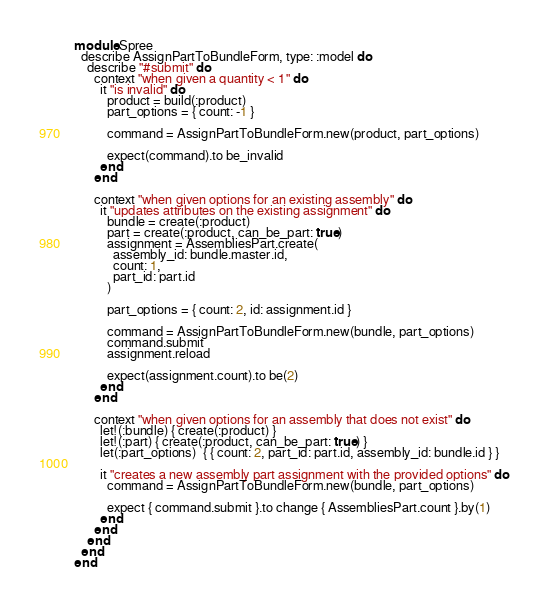<code> <loc_0><loc_0><loc_500><loc_500><_Ruby_>module Spree
  describe AssignPartToBundleForm, type: :model do
    describe "#submit" do
      context "when given a quantity < 1" do
        it "is invalid" do
          product = build(:product)
          part_options = { count: -1 }

          command = AssignPartToBundleForm.new(product, part_options)

          expect(command).to be_invalid
        end
      end

      context "when given options for an existing assembly" do
        it "updates attributes on the existing assignment" do
          bundle = create(:product)
          part = create(:product, can_be_part: true)
          assignment = AssembliesPart.create(
            assembly_id: bundle.master.id,
            count: 1,
            part_id: part.id
          )

          part_options = { count: 2, id: assignment.id }

          command = AssignPartToBundleForm.new(bundle, part_options)
          command.submit
          assignment.reload

          expect(assignment.count).to be(2)
        end
      end

      context "when given options for an assembly that does not exist" do
        let!(:bundle) { create(:product) }
        let!(:part) { create(:product, can_be_part: true) }
        let(:part_options)  { { count: 2, part_id: part.id, assembly_id: bundle.id } }

        it "creates a new assembly part assignment with the provided options" do
          command = AssignPartToBundleForm.new(bundle, part_options)

          expect { command.submit }.to change { AssembliesPart.count }.by(1)
        end
      end
    end
  end
end</code> 